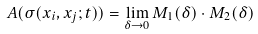<formula> <loc_0><loc_0><loc_500><loc_500>A ( \sigma ( x _ { i } , x _ { j } ; t ) ) = \lim _ { \delta \to 0 } M _ { 1 } ( \delta ) \cdot M _ { 2 } ( \delta )</formula> 